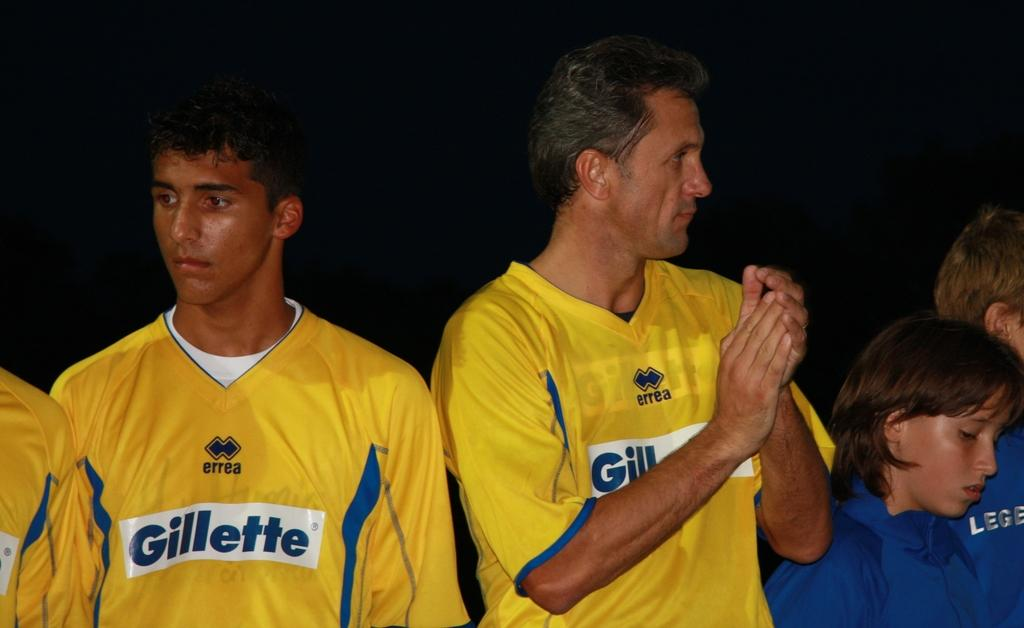<image>
Describe the image concisely. people in yellow Gillette sports jerseys outside at night 